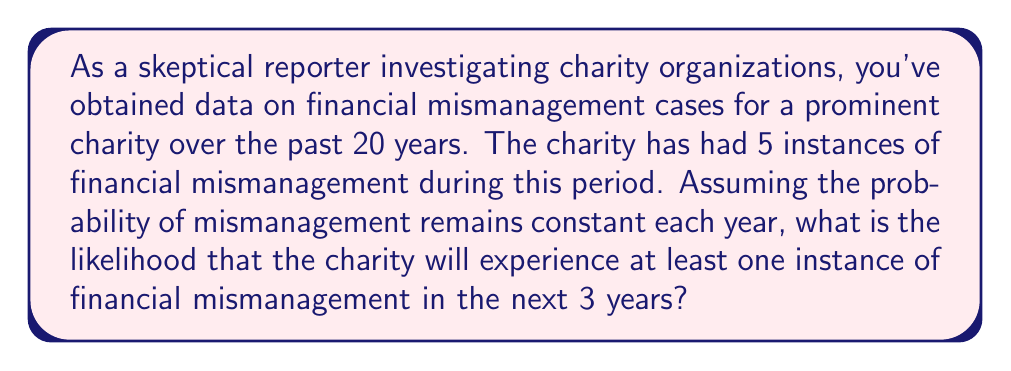Show me your answer to this math problem. To solve this problem, we'll use the Poisson distribution, which is suitable for modeling rare events over a fixed period. Let's break it down step-by-step:

1. Calculate the rate (λ) of financial mismanagement per year:
   $$ \lambda = \frac{5 \text{ instances}}{20 \text{ years}} = 0.25 \text{ instances/year} $$

2. For a 3-year period, the rate becomes:
   $$ \lambda_{3 \text{ years}} = 0.25 \times 3 = 0.75 $$

3. We want to find the probability of at least one instance in 3 years. This is equivalent to 1 minus the probability of zero instances:
   $$ P(\text{at least one}) = 1 - P(\text{zero}) $$

4. The probability of zero instances in a Poisson distribution is given by:
   $$ P(X = 0) = \frac{e^{-\lambda} \lambda^0}{0!} = e^{-\lambda} $$

5. Substituting our λ value:
   $$ P(\text{zero}) = e^{-0.75} $$

6. Therefore, the probability of at least one instance is:
   $$ P(\text{at least one}) = 1 - e^{-0.75} $$

7. Calculating this value:
   $$ P(\text{at least one}) = 1 - e^{-0.75} \approx 0.5276 $$
Answer: The likelihood that the charity will experience at least one instance of financial mismanagement in the next 3 years is approximately 0.5276 or 52.76%. 